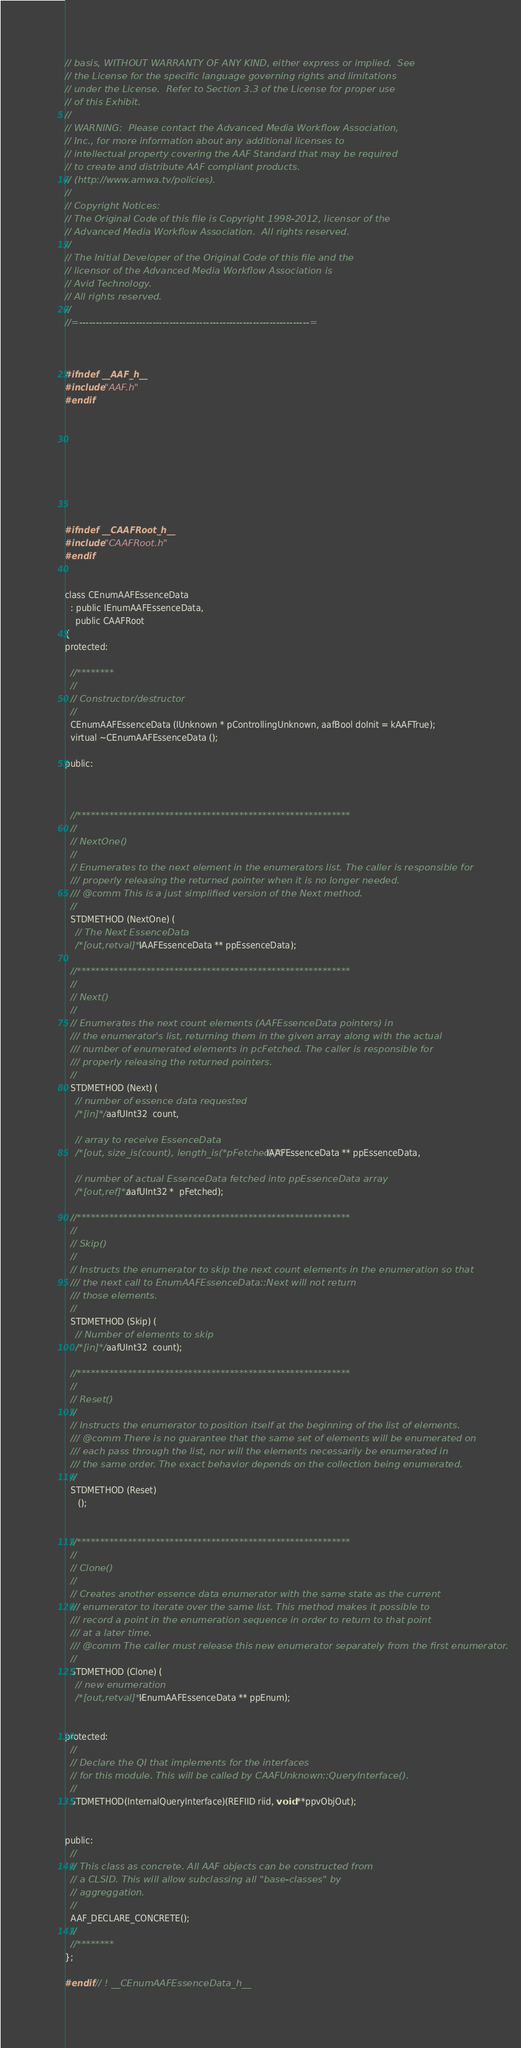Convert code to text. <code><loc_0><loc_0><loc_500><loc_500><_C_>// basis, WITHOUT WARRANTY OF ANY KIND, either express or implied.  See
// the License for the specific language governing rights and limitations
// under the License.  Refer to Section 3.3 of the License for proper use
// of this Exhibit.
//
// WARNING:  Please contact the Advanced Media Workflow Association,
// Inc., for more information about any additional licenses to
// intellectual property covering the AAF Standard that may be required
// to create and distribute AAF compliant products.
// (http://www.amwa.tv/policies).
//
// Copyright Notices:
// The Original Code of this file is Copyright 1998-2012, licensor of the
// Advanced Media Workflow Association.  All rights reserved.
//
// The Initial Developer of the Original Code of this file and the
// licensor of the Advanced Media Workflow Association is
// Avid Technology.
// All rights reserved.
//
//=---------------------------------------------------------------------=



#ifndef __AAF_h__
#include "AAF.h"
#endif









#ifndef __CAAFRoot_h__
#include "CAAFRoot.h"
#endif


class CEnumAAFEssenceData
  : public IEnumAAFEssenceData,
    public CAAFRoot
{
protected:

  //********
  //
  // Constructor/destructor
  //
  CEnumAAFEssenceData (IUnknown * pControllingUnknown, aafBool doInit = kAAFTrue);
  virtual ~CEnumAAFEssenceData ();

public:



  //***********************************************************
  //
  // NextOne()
  //
  // Enumerates to the next element in the enumerators list. The caller is responsible for 
  /// properly releasing the returned pointer when it is no longer needed.
  /// @comm This is a just simplified version of the Next method. 
  //
  STDMETHOD (NextOne) (
    // The Next EssenceData 
    /*[out,retval]*/ IAAFEssenceData ** ppEssenceData);

  //***********************************************************
  //
  // Next()
  //
  // Enumerates the next count elements (AAFEssenceData pointers) in 
  /// the enumerator's list, returning them in the given array along with the actual 
  /// number of enumerated elements in pcFetched. The caller is responsible for 
  /// properly releasing the returned pointers.
  //
  STDMETHOD (Next) (
    // number of essence data requested
    /*[in]*/ aafUInt32  count,

    // array to receive EssenceData
    /*[out, size_is(count), length_is(*pFetched)]*/ IAAFEssenceData ** ppEssenceData,

    // number of actual EssenceData fetched into ppEssenceData array
    /*[out,ref]*/ aafUInt32 *  pFetched);

  //***********************************************************
  //
  // Skip()
  //
  // Instructs the enumerator to skip the next count elements in the enumeration so that 
  /// the next call to EnumAAFEssenceData::Next will not return 
  /// those elements.
  //
  STDMETHOD (Skip) (
    // Number of elements to skip 
    /*[in]*/ aafUInt32  count);

  //***********************************************************
  //
  // Reset()
  //
  // Instructs the enumerator to position itself at the beginning of the list of elements. 
  /// @comm There is no guarantee that the same set of elements will be enumerated on 
  /// each pass through the list, nor will the elements necessarily be enumerated in 
  /// the same order. The exact behavior depends on the collection being enumerated.
  //
  STDMETHOD (Reset)
     ();


  //***********************************************************
  //
  // Clone()
  //
  // Creates another essence data enumerator with the same state as the current 
  /// enumerator to iterate over the same list. This method makes it possible to 
  /// record a point in the enumeration sequence in order to return to that point 
  /// at a later time.
  /// @comm The caller must release this new enumerator separately from the first enumerator.
  //
  STDMETHOD (Clone) (
    // new enumeration 
    /*[out,retval]*/ IEnumAAFEssenceData ** ppEnum);


protected:
  // 
  // Declare the QI that implements for the interfaces
  // for this module. This will be called by CAAFUnknown::QueryInterface().
  // 
  STDMETHOD(InternalQueryInterface)(REFIID riid, void **ppvObjOut);


public:
  //
  // This class as concrete. All AAF objects can be constructed from
  // a CLSID. This will allow subclassing all "base-classes" by
  // aggreggation.
  // 
  AAF_DECLARE_CONCRETE();
  //
  //********
};

#endif // ! __CEnumAAFEssenceData_h__


</code> 